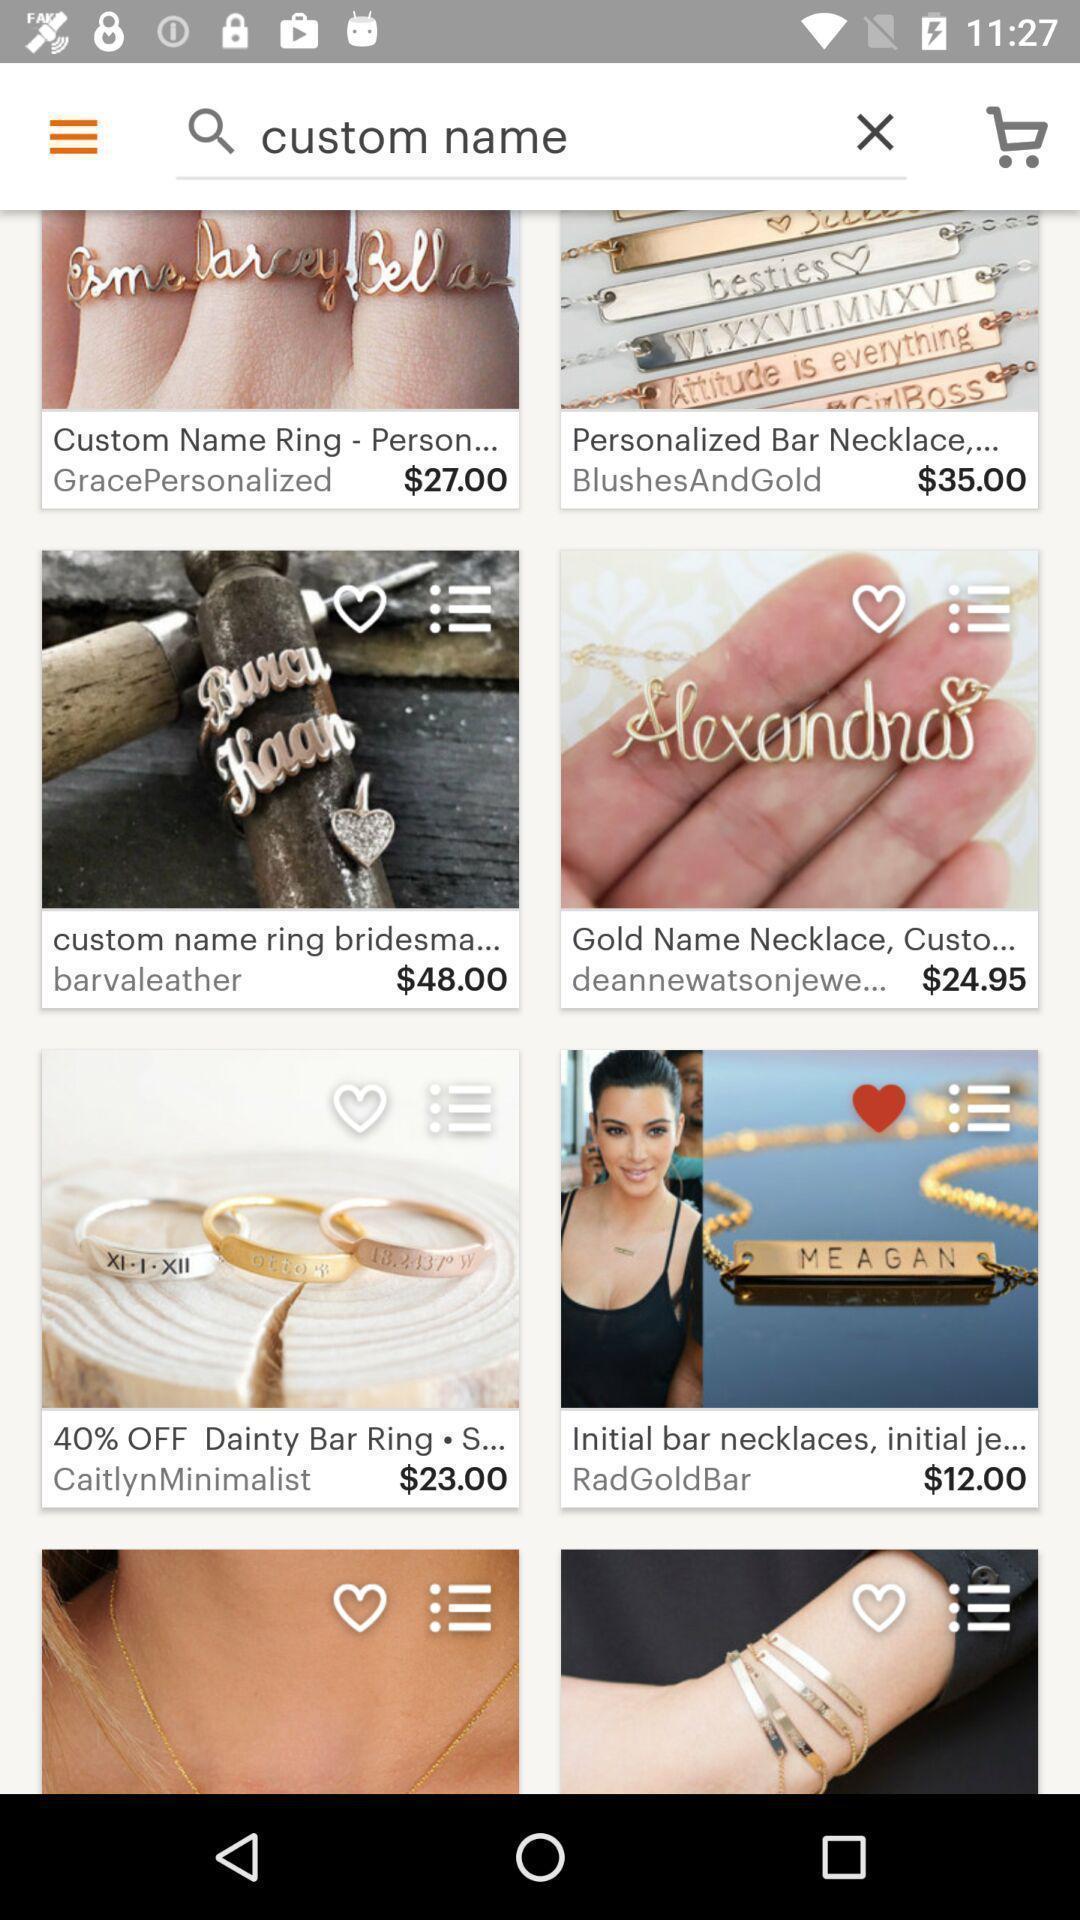Describe this image in words. Search result page of products in shopping app. 